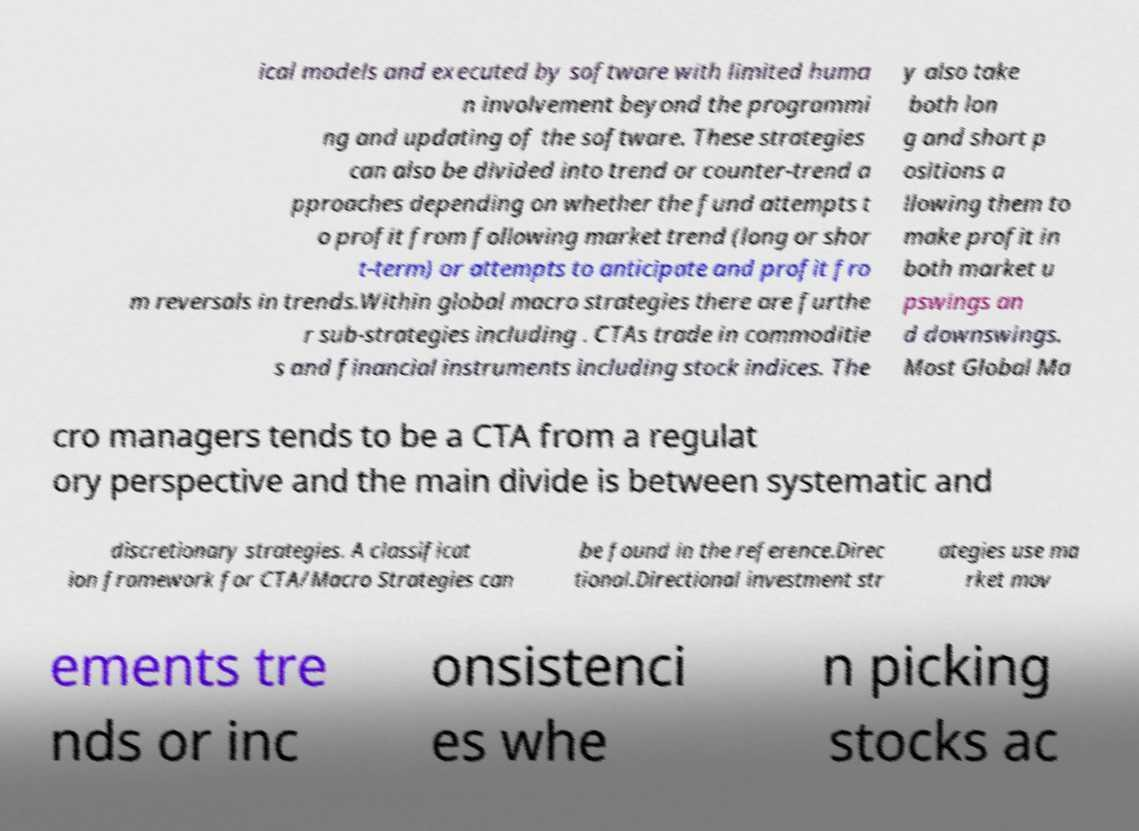Could you extract and type out the text from this image? ical models and executed by software with limited huma n involvement beyond the programmi ng and updating of the software. These strategies can also be divided into trend or counter-trend a pproaches depending on whether the fund attempts t o profit from following market trend (long or shor t-term) or attempts to anticipate and profit fro m reversals in trends.Within global macro strategies there are furthe r sub-strategies including . CTAs trade in commoditie s and financial instruments including stock indices. The y also take both lon g and short p ositions a llowing them to make profit in both market u pswings an d downswings. Most Global Ma cro managers tends to be a CTA from a regulat ory perspective and the main divide is between systematic and discretionary strategies. A classificat ion framework for CTA/Macro Strategies can be found in the reference.Direc tional.Directional investment str ategies use ma rket mov ements tre nds or inc onsistenci es whe n picking stocks ac 